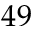<formula> <loc_0><loc_0><loc_500><loc_500>4 9</formula> 